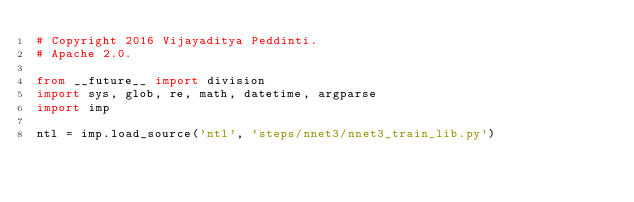<code> <loc_0><loc_0><loc_500><loc_500><_Python_># Copyright 2016 Vijayaditya Peddinti.
# Apache 2.0.

from __future__ import division
import sys, glob, re, math, datetime, argparse
import imp

ntl = imp.load_source('ntl', 'steps/nnet3/nnet3_train_lib.py')
</code> 